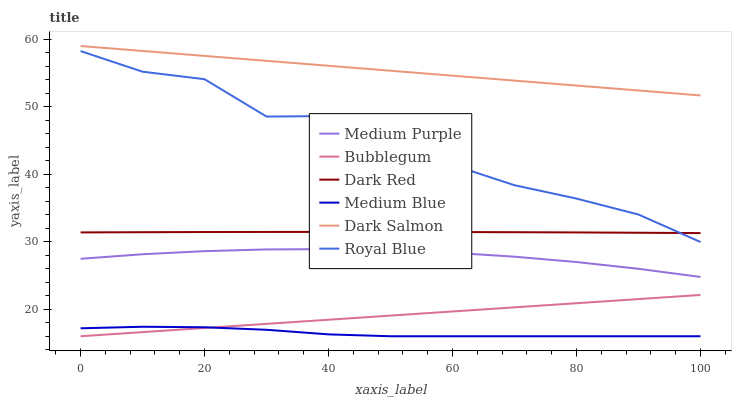Does Medium Blue have the minimum area under the curve?
Answer yes or no. Yes. Does Dark Salmon have the maximum area under the curve?
Answer yes or no. Yes. Does Dark Salmon have the minimum area under the curve?
Answer yes or no. No. Does Medium Blue have the maximum area under the curve?
Answer yes or no. No. Is Bubblegum the smoothest?
Answer yes or no. Yes. Is Royal Blue the roughest?
Answer yes or no. Yes. Is Medium Blue the smoothest?
Answer yes or no. No. Is Medium Blue the roughest?
Answer yes or no. No. Does Medium Blue have the lowest value?
Answer yes or no. Yes. Does Dark Salmon have the lowest value?
Answer yes or no. No. Does Dark Salmon have the highest value?
Answer yes or no. Yes. Does Medium Blue have the highest value?
Answer yes or no. No. Is Royal Blue less than Dark Salmon?
Answer yes or no. Yes. Is Medium Purple greater than Bubblegum?
Answer yes or no. Yes. Does Bubblegum intersect Medium Blue?
Answer yes or no. Yes. Is Bubblegum less than Medium Blue?
Answer yes or no. No. Is Bubblegum greater than Medium Blue?
Answer yes or no. No. Does Royal Blue intersect Dark Salmon?
Answer yes or no. No. 